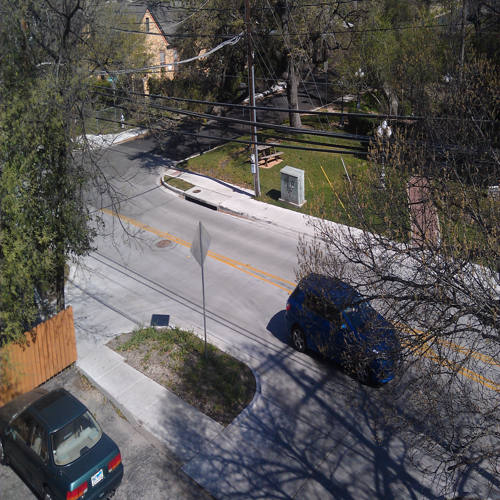What can you infer about the area from the types of vehicles seen in the image? From the presence of personal vehicles like a blue SUV and a red sedan, we can infer that this is a residential area where people rely on individual transport rather than public transportation. The cars appear to be in good condition, which might suggest a middle-income neighborhood. Is there anything in the image that indicates the level of activity in this area? The absence of pedestrians, bicycles, or signs of movement suggests a low level of activity at the time the photo was taken. However, this might not be an accurate depiction of activity levels at all times, as it could be a momentary lull or the picture might have been taken at a generally quiet time of day. 